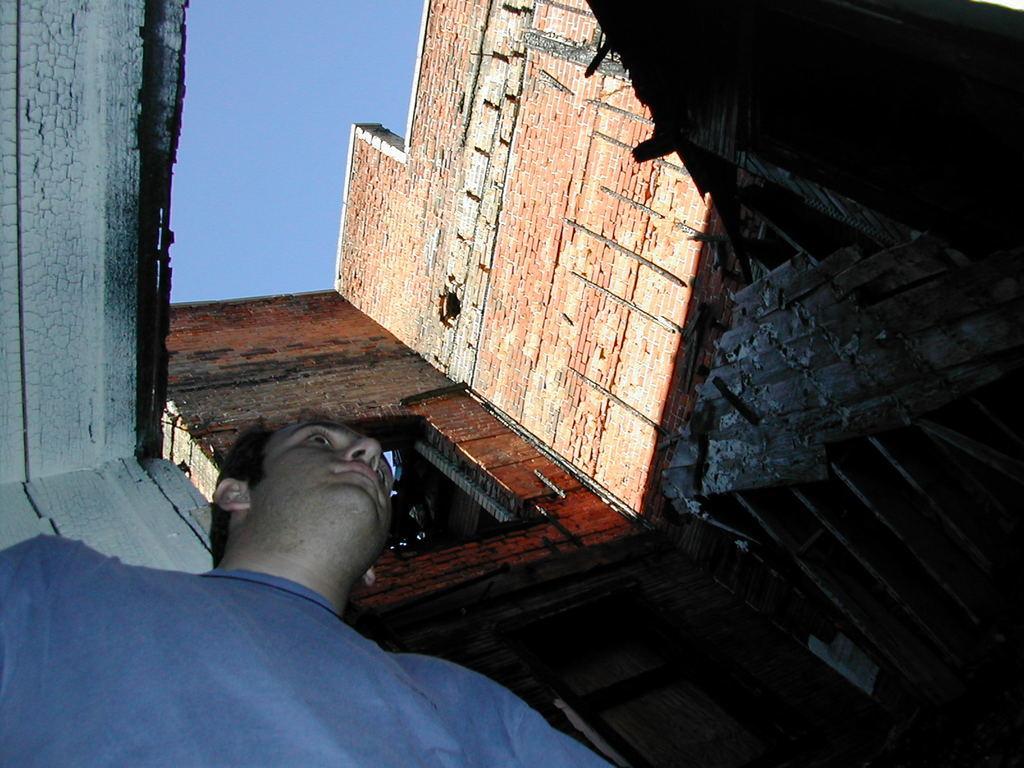Describe this image in one or two sentences. In this picture there is a building. In the left bottom there is a person with blue t-shirt. At the top there is sky. 